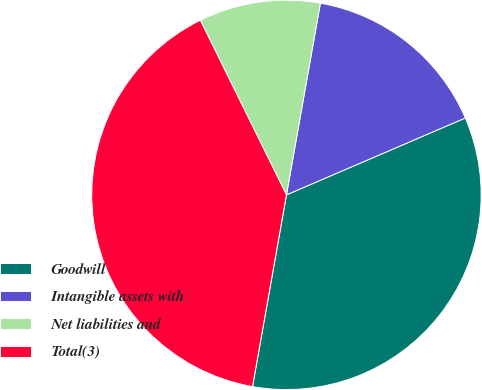Convert chart to OTSL. <chart><loc_0><loc_0><loc_500><loc_500><pie_chart><fcel>Goodwill<fcel>Intangible assets with<fcel>Net liabilities and<fcel>Total(3)<nl><fcel>34.25%<fcel>15.75%<fcel>10.08%<fcel>39.92%<nl></chart> 